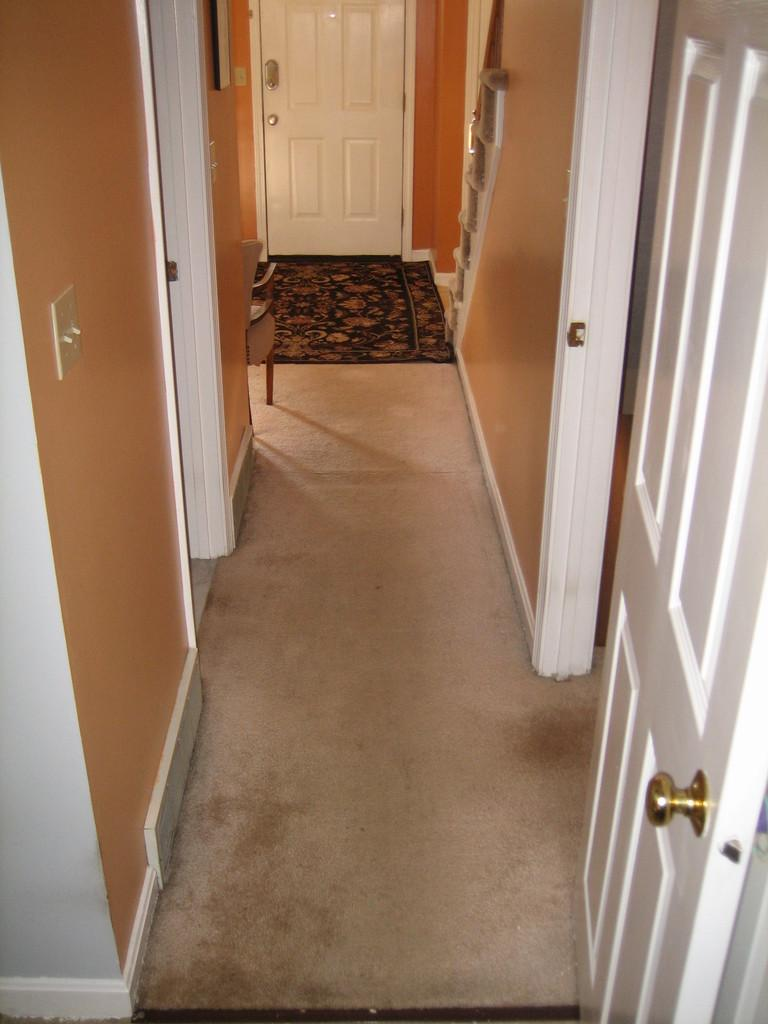What is one of the main architectural features in the image? There is a door in the image. What else can be seen in the image that might be part of a room or building? There are walls in the image. What type of furniture is present in the image? There is a chair in the image. Can you describe any other objects that are visible in the image? There are objects in the image, but their specific nature is not mentioned in the facts. What is on the floor in the background of the image? There is a mat on the floor in the background of the image. Is there another door visible in the image? Yes, there is a door visible in the background of the image. What type of plant is growing on the car in the image? There is no car or plant present in the image. 